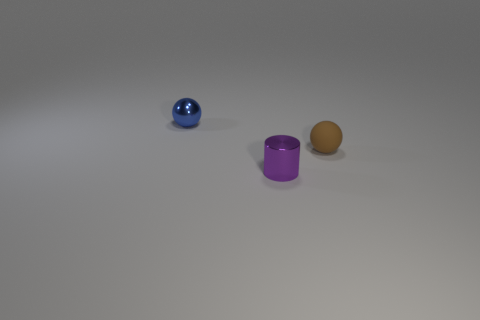There is a tiny sphere in front of the thing to the left of the purple cylinder; what is its material?
Ensure brevity in your answer.  Rubber. What is the size of the brown thing that is the same shape as the small blue metallic thing?
Your answer should be very brief. Small. There is a tiny ball that is on the right side of the tiny shiny cylinder; is it the same color as the small cylinder?
Offer a very short reply. No. Does the tiny sphere in front of the tiny blue thing have the same material as the tiny cylinder?
Your answer should be very brief. No. What is the material of the sphere left of the brown matte thing?
Your response must be concise. Metal. There is a ball right of the tiny metallic thing that is right of the tiny blue metal object; how big is it?
Your response must be concise. Small. The metallic object that is to the left of the shiny object in front of the tiny sphere to the left of the purple object is what shape?
Your answer should be compact. Sphere. There is a ball that is behind the tiny brown rubber sphere; does it have the same color as the metal thing that is right of the blue object?
Provide a short and direct response. No. There is a metallic thing that is in front of the small metallic object that is behind the metallic thing that is in front of the tiny brown ball; what is its color?
Keep it short and to the point. Purple. Does the tiny sphere that is in front of the tiny blue metallic thing have the same material as the tiny ball behind the tiny brown sphere?
Ensure brevity in your answer.  No. 